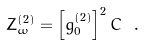<formula> <loc_0><loc_0><loc_500><loc_500>Z _ { \omega } ^ { ( 2 ) } = \left [ \bar { g } _ { 0 } ^ { ( 2 ) } \right ] ^ { 2 } C \ .</formula> 